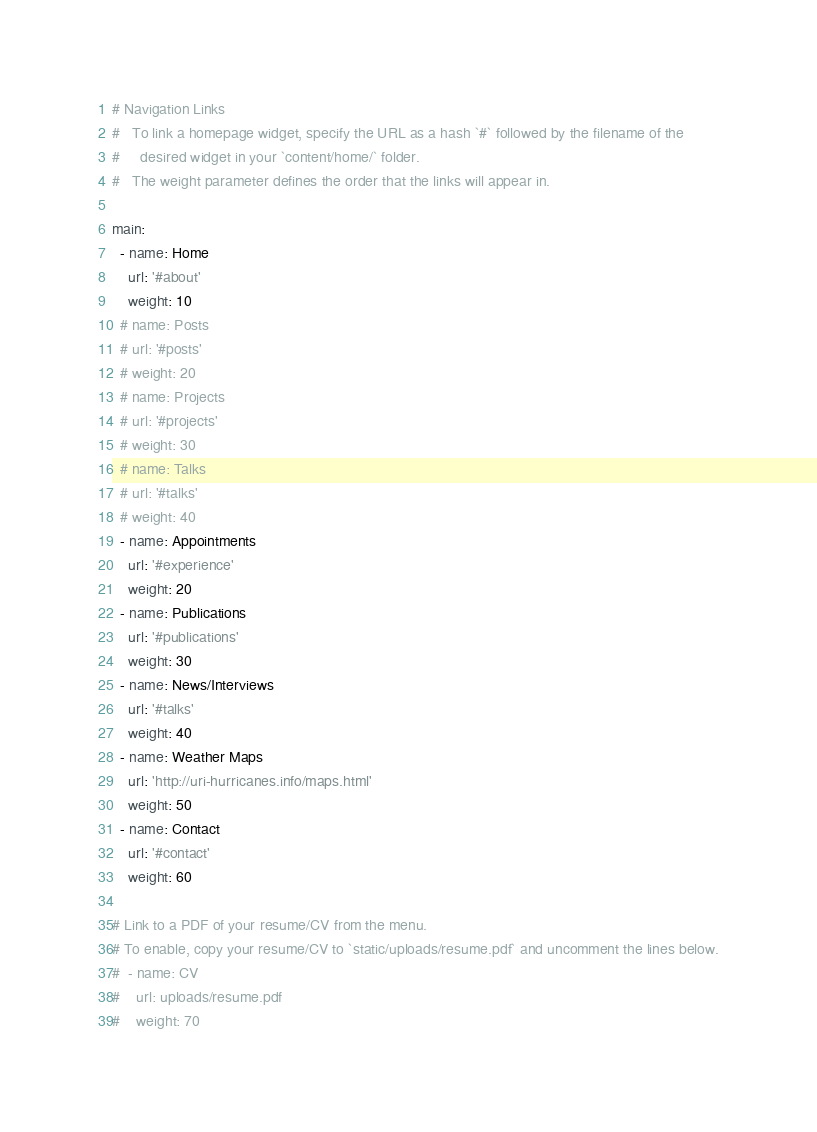<code> <loc_0><loc_0><loc_500><loc_500><_YAML_># Navigation Links
#   To link a homepage widget, specify the URL as a hash `#` followed by the filename of the
#     desired widget in your `content/home/` folder.
#   The weight parameter defines the order that the links will appear in.

main:
  - name: Home
    url: '#about'
    weight: 10
  # name: Posts
  # url: '#posts'
  # weight: 20
  # name: Projects
  # url: '#projects'
  # weight: 30
  # name: Talks
  # url: '#talks'
  # weight: 40
  - name: Appointments
    url: '#experience'
    weight: 20
  - name: Publications
    url: '#publications'
    weight: 30
  - name: News/Interviews
    url: '#talks'
    weight: 40
  - name: Weather Maps
    url: 'http://uri-hurricanes.info/maps.html'
    weight: 50 
  - name: Contact
    url: '#contact'
    weight: 60

# Link to a PDF of your resume/CV from the menu.
# To enable, copy your resume/CV to `static/uploads/resume.pdf` and uncomment the lines below.
#  - name: CV
#    url: uploads/resume.pdf
#    weight: 70
</code> 